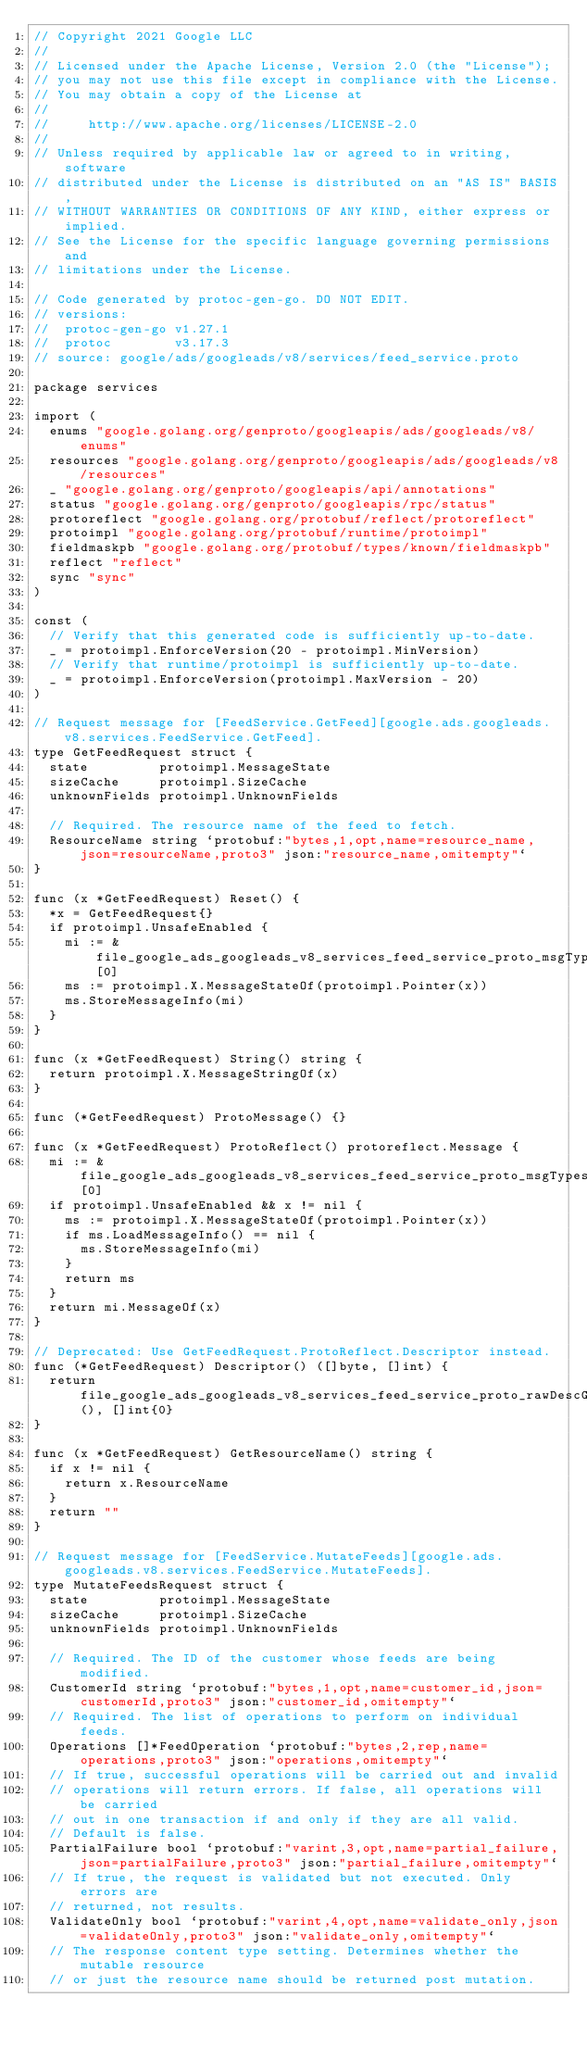<code> <loc_0><loc_0><loc_500><loc_500><_Go_>// Copyright 2021 Google LLC
//
// Licensed under the Apache License, Version 2.0 (the "License");
// you may not use this file except in compliance with the License.
// You may obtain a copy of the License at
//
//     http://www.apache.org/licenses/LICENSE-2.0
//
// Unless required by applicable law or agreed to in writing, software
// distributed under the License is distributed on an "AS IS" BASIS,
// WITHOUT WARRANTIES OR CONDITIONS OF ANY KIND, either express or implied.
// See the License for the specific language governing permissions and
// limitations under the License.

// Code generated by protoc-gen-go. DO NOT EDIT.
// versions:
// 	protoc-gen-go v1.27.1
// 	protoc        v3.17.3
// source: google/ads/googleads/v8/services/feed_service.proto

package services

import (
	enums "google.golang.org/genproto/googleapis/ads/googleads/v8/enums"
	resources "google.golang.org/genproto/googleapis/ads/googleads/v8/resources"
	_ "google.golang.org/genproto/googleapis/api/annotations"
	status "google.golang.org/genproto/googleapis/rpc/status"
	protoreflect "google.golang.org/protobuf/reflect/protoreflect"
	protoimpl "google.golang.org/protobuf/runtime/protoimpl"
	fieldmaskpb "google.golang.org/protobuf/types/known/fieldmaskpb"
	reflect "reflect"
	sync "sync"
)

const (
	// Verify that this generated code is sufficiently up-to-date.
	_ = protoimpl.EnforceVersion(20 - protoimpl.MinVersion)
	// Verify that runtime/protoimpl is sufficiently up-to-date.
	_ = protoimpl.EnforceVersion(protoimpl.MaxVersion - 20)
)

// Request message for [FeedService.GetFeed][google.ads.googleads.v8.services.FeedService.GetFeed].
type GetFeedRequest struct {
	state         protoimpl.MessageState
	sizeCache     protoimpl.SizeCache
	unknownFields protoimpl.UnknownFields

	// Required. The resource name of the feed to fetch.
	ResourceName string `protobuf:"bytes,1,opt,name=resource_name,json=resourceName,proto3" json:"resource_name,omitempty"`
}

func (x *GetFeedRequest) Reset() {
	*x = GetFeedRequest{}
	if protoimpl.UnsafeEnabled {
		mi := &file_google_ads_googleads_v8_services_feed_service_proto_msgTypes[0]
		ms := protoimpl.X.MessageStateOf(protoimpl.Pointer(x))
		ms.StoreMessageInfo(mi)
	}
}

func (x *GetFeedRequest) String() string {
	return protoimpl.X.MessageStringOf(x)
}

func (*GetFeedRequest) ProtoMessage() {}

func (x *GetFeedRequest) ProtoReflect() protoreflect.Message {
	mi := &file_google_ads_googleads_v8_services_feed_service_proto_msgTypes[0]
	if protoimpl.UnsafeEnabled && x != nil {
		ms := protoimpl.X.MessageStateOf(protoimpl.Pointer(x))
		if ms.LoadMessageInfo() == nil {
			ms.StoreMessageInfo(mi)
		}
		return ms
	}
	return mi.MessageOf(x)
}

// Deprecated: Use GetFeedRequest.ProtoReflect.Descriptor instead.
func (*GetFeedRequest) Descriptor() ([]byte, []int) {
	return file_google_ads_googleads_v8_services_feed_service_proto_rawDescGZIP(), []int{0}
}

func (x *GetFeedRequest) GetResourceName() string {
	if x != nil {
		return x.ResourceName
	}
	return ""
}

// Request message for [FeedService.MutateFeeds][google.ads.googleads.v8.services.FeedService.MutateFeeds].
type MutateFeedsRequest struct {
	state         protoimpl.MessageState
	sizeCache     protoimpl.SizeCache
	unknownFields protoimpl.UnknownFields

	// Required. The ID of the customer whose feeds are being modified.
	CustomerId string `protobuf:"bytes,1,opt,name=customer_id,json=customerId,proto3" json:"customer_id,omitempty"`
	// Required. The list of operations to perform on individual feeds.
	Operations []*FeedOperation `protobuf:"bytes,2,rep,name=operations,proto3" json:"operations,omitempty"`
	// If true, successful operations will be carried out and invalid
	// operations will return errors. If false, all operations will be carried
	// out in one transaction if and only if they are all valid.
	// Default is false.
	PartialFailure bool `protobuf:"varint,3,opt,name=partial_failure,json=partialFailure,proto3" json:"partial_failure,omitempty"`
	// If true, the request is validated but not executed. Only errors are
	// returned, not results.
	ValidateOnly bool `protobuf:"varint,4,opt,name=validate_only,json=validateOnly,proto3" json:"validate_only,omitempty"`
	// The response content type setting. Determines whether the mutable resource
	// or just the resource name should be returned post mutation.</code> 